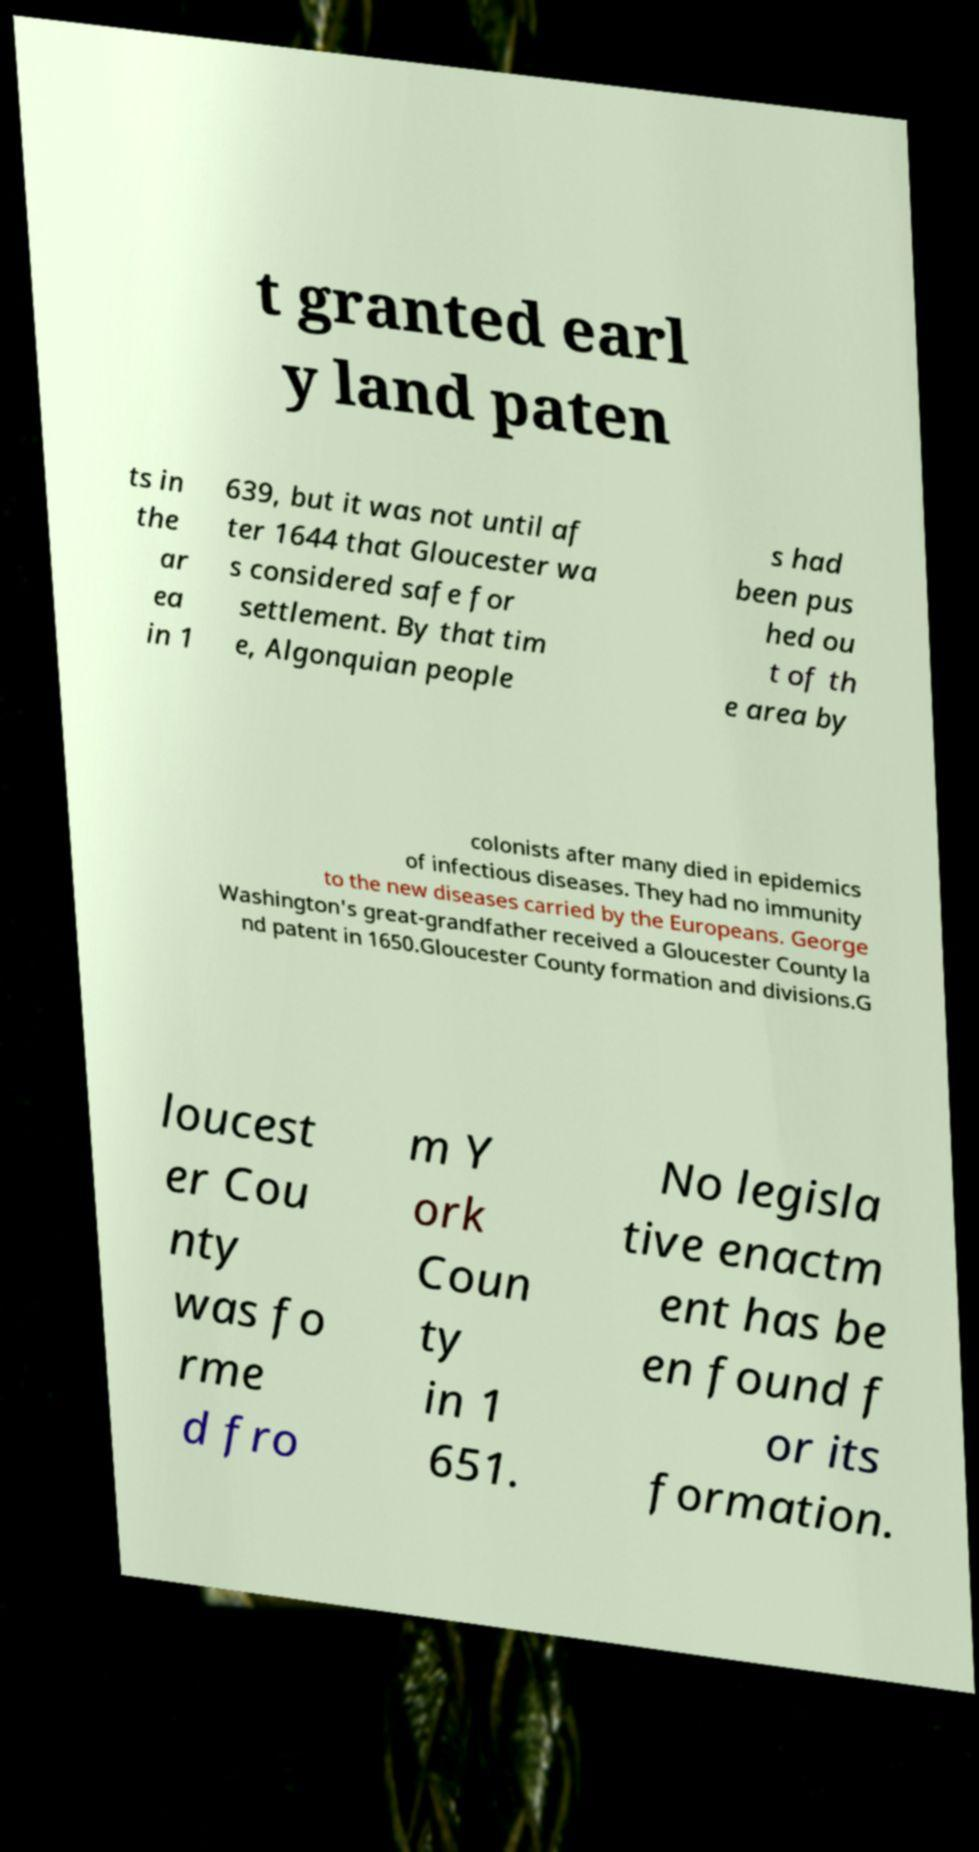There's text embedded in this image that I need extracted. Can you transcribe it verbatim? t granted earl y land paten ts in the ar ea in 1 639, but it was not until af ter 1644 that Gloucester wa s considered safe for settlement. By that tim e, Algonquian people s had been pus hed ou t of th e area by colonists after many died in epidemics of infectious diseases. They had no immunity to the new diseases carried by the Europeans. George Washington's great-grandfather received a Gloucester County la nd patent in 1650.Gloucester County formation and divisions.G loucest er Cou nty was fo rme d fro m Y ork Coun ty in 1 651. No legisla tive enactm ent has be en found f or its formation. 